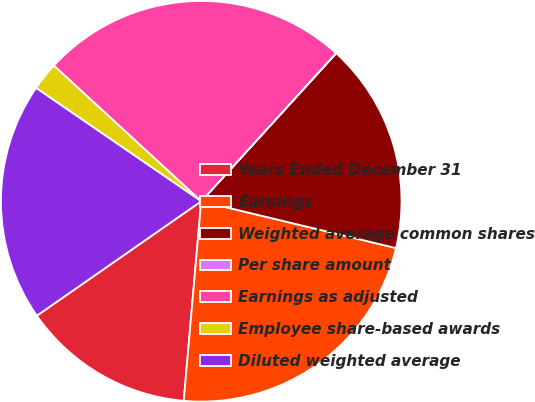<chart> <loc_0><loc_0><loc_500><loc_500><pie_chart><fcel>Years Ended December 31<fcel>Earnings<fcel>Weighted average common shares<fcel>Per share amount<fcel>Earnings as adjusted<fcel>Employee share-based awards<fcel>Diluted weighted average<nl><fcel>13.93%<fcel>22.64%<fcel>16.99%<fcel>0.01%<fcel>24.91%<fcel>2.27%<fcel>19.25%<nl></chart> 